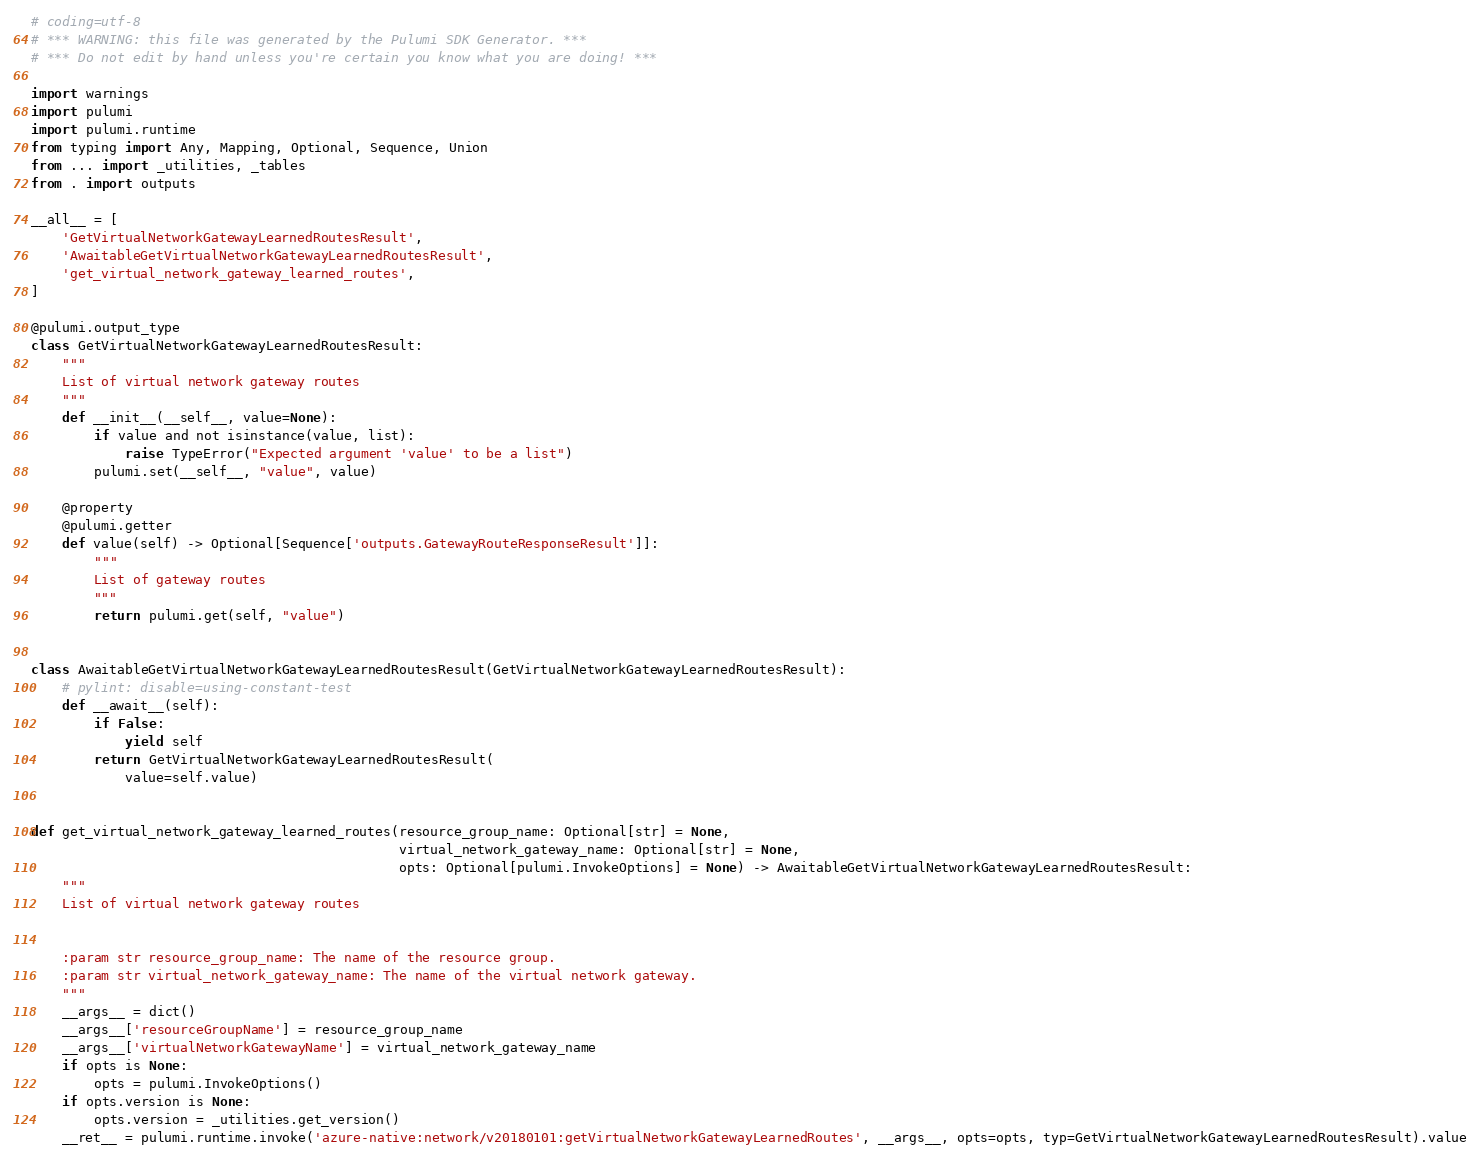Convert code to text. <code><loc_0><loc_0><loc_500><loc_500><_Python_># coding=utf-8
# *** WARNING: this file was generated by the Pulumi SDK Generator. ***
# *** Do not edit by hand unless you're certain you know what you are doing! ***

import warnings
import pulumi
import pulumi.runtime
from typing import Any, Mapping, Optional, Sequence, Union
from ... import _utilities, _tables
from . import outputs

__all__ = [
    'GetVirtualNetworkGatewayLearnedRoutesResult',
    'AwaitableGetVirtualNetworkGatewayLearnedRoutesResult',
    'get_virtual_network_gateway_learned_routes',
]

@pulumi.output_type
class GetVirtualNetworkGatewayLearnedRoutesResult:
    """
    List of virtual network gateway routes
    """
    def __init__(__self__, value=None):
        if value and not isinstance(value, list):
            raise TypeError("Expected argument 'value' to be a list")
        pulumi.set(__self__, "value", value)

    @property
    @pulumi.getter
    def value(self) -> Optional[Sequence['outputs.GatewayRouteResponseResult']]:
        """
        List of gateway routes
        """
        return pulumi.get(self, "value")


class AwaitableGetVirtualNetworkGatewayLearnedRoutesResult(GetVirtualNetworkGatewayLearnedRoutesResult):
    # pylint: disable=using-constant-test
    def __await__(self):
        if False:
            yield self
        return GetVirtualNetworkGatewayLearnedRoutesResult(
            value=self.value)


def get_virtual_network_gateway_learned_routes(resource_group_name: Optional[str] = None,
                                               virtual_network_gateway_name: Optional[str] = None,
                                               opts: Optional[pulumi.InvokeOptions] = None) -> AwaitableGetVirtualNetworkGatewayLearnedRoutesResult:
    """
    List of virtual network gateway routes


    :param str resource_group_name: The name of the resource group.
    :param str virtual_network_gateway_name: The name of the virtual network gateway.
    """
    __args__ = dict()
    __args__['resourceGroupName'] = resource_group_name
    __args__['virtualNetworkGatewayName'] = virtual_network_gateway_name
    if opts is None:
        opts = pulumi.InvokeOptions()
    if opts.version is None:
        opts.version = _utilities.get_version()
    __ret__ = pulumi.runtime.invoke('azure-native:network/v20180101:getVirtualNetworkGatewayLearnedRoutes', __args__, opts=opts, typ=GetVirtualNetworkGatewayLearnedRoutesResult).value
</code> 